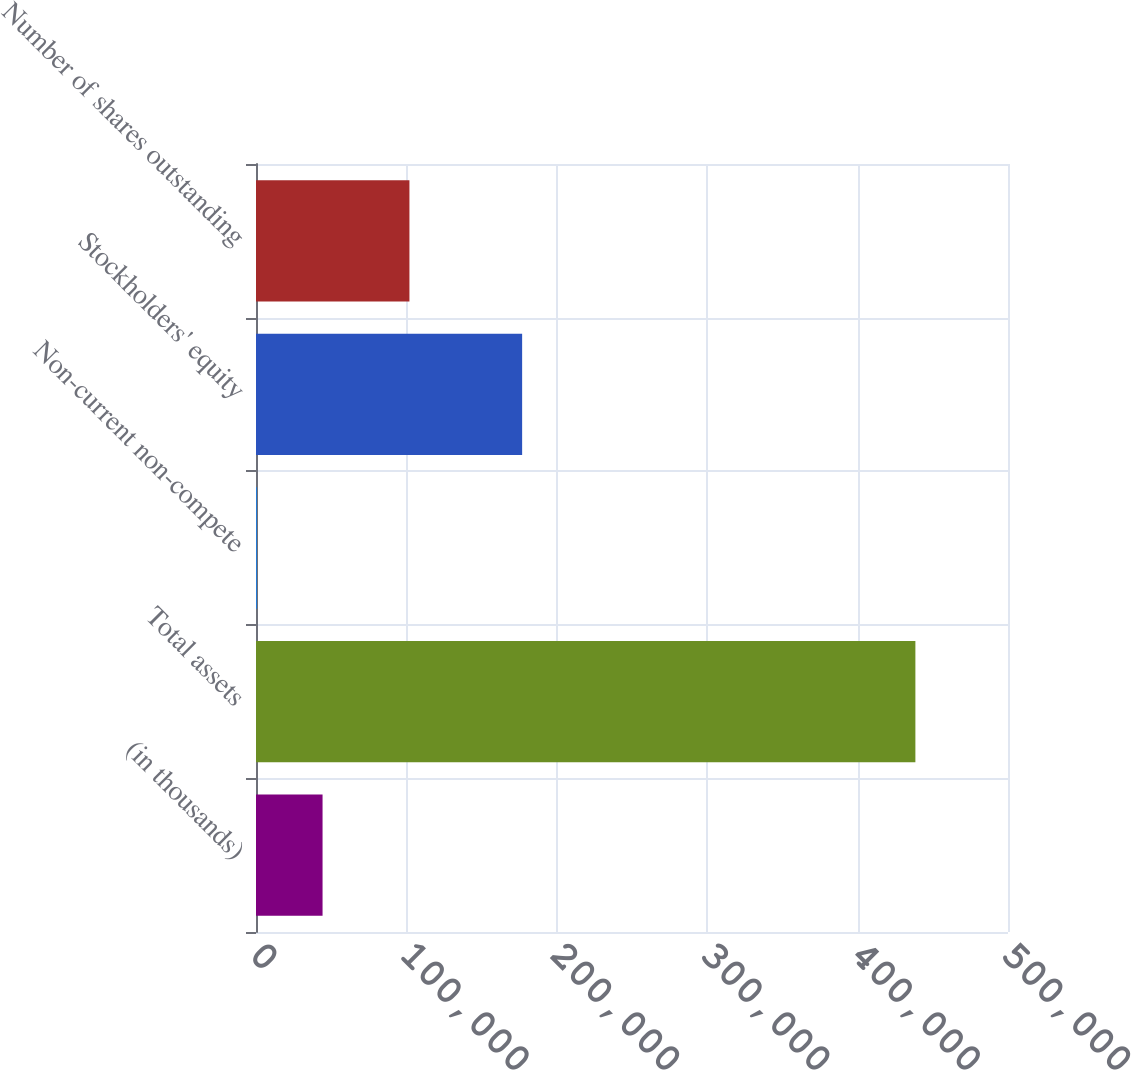Convert chart to OTSL. <chart><loc_0><loc_0><loc_500><loc_500><bar_chart><fcel>(in thousands)<fcel>Total assets<fcel>Non-current non-compete<fcel>Stockholders' equity<fcel>Number of shares outstanding<nl><fcel>44252.4<fcel>438420<fcel>456<fcel>176951<fcel>102017<nl></chart> 